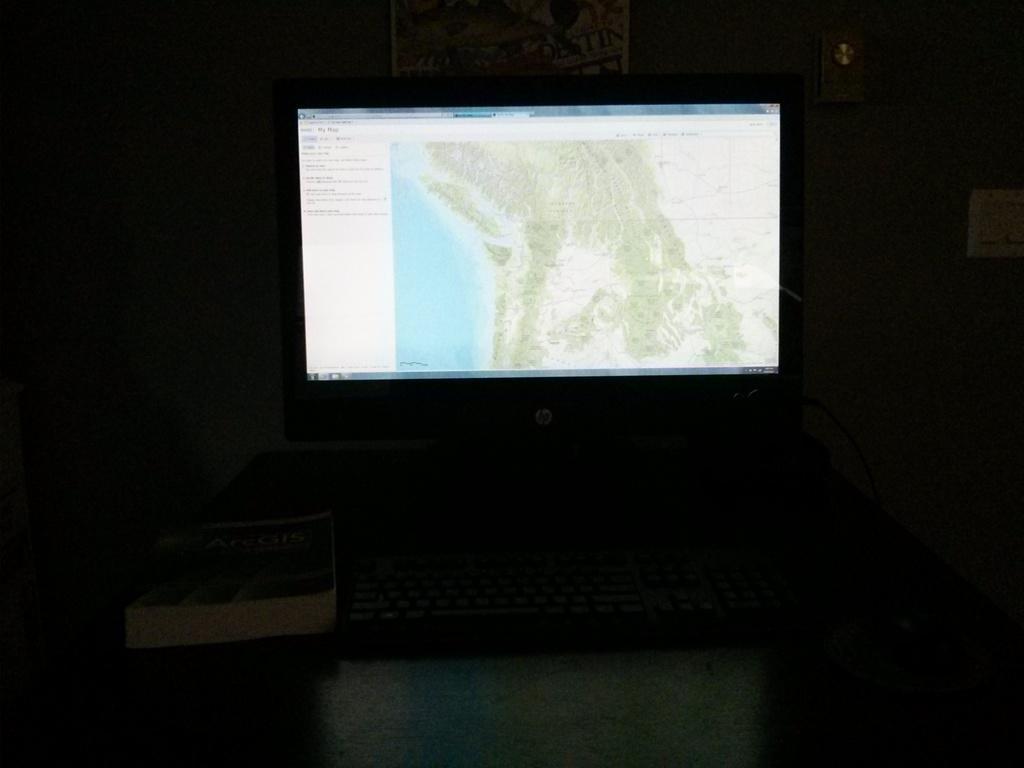How would you summarize this image in a sentence or two? In this image I can see a system and I can also see a book and I can see dark background. 